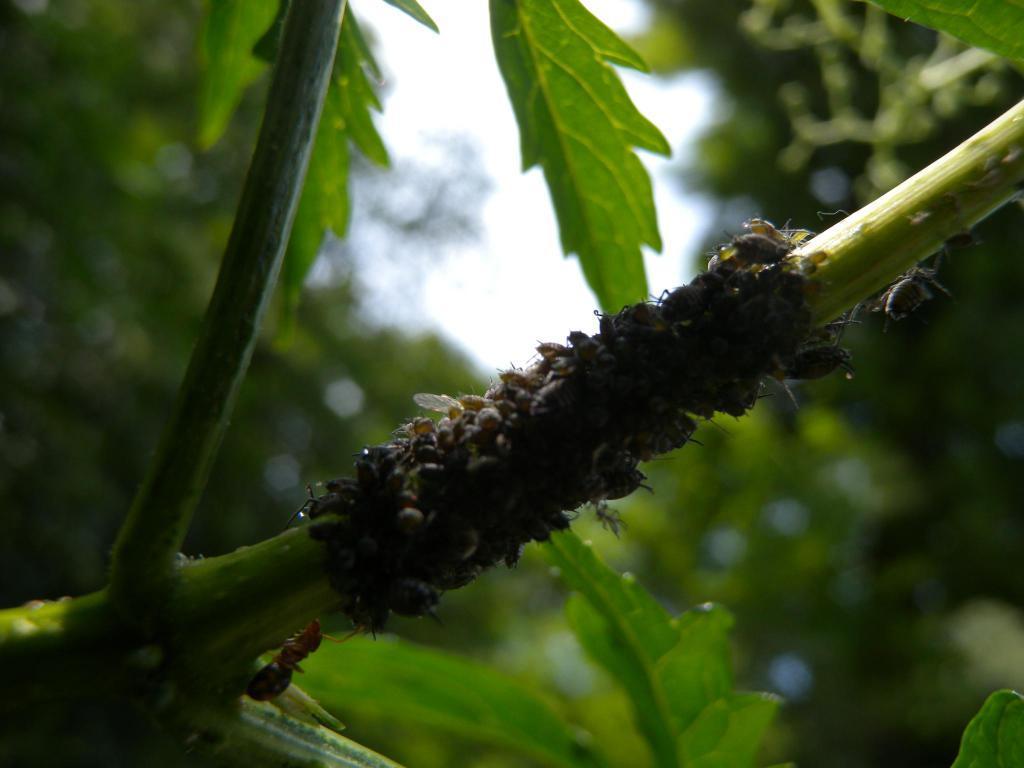Can you describe this image briefly? In the image there are many insects to the branch of a tree and behind the branch the background is blurry. 